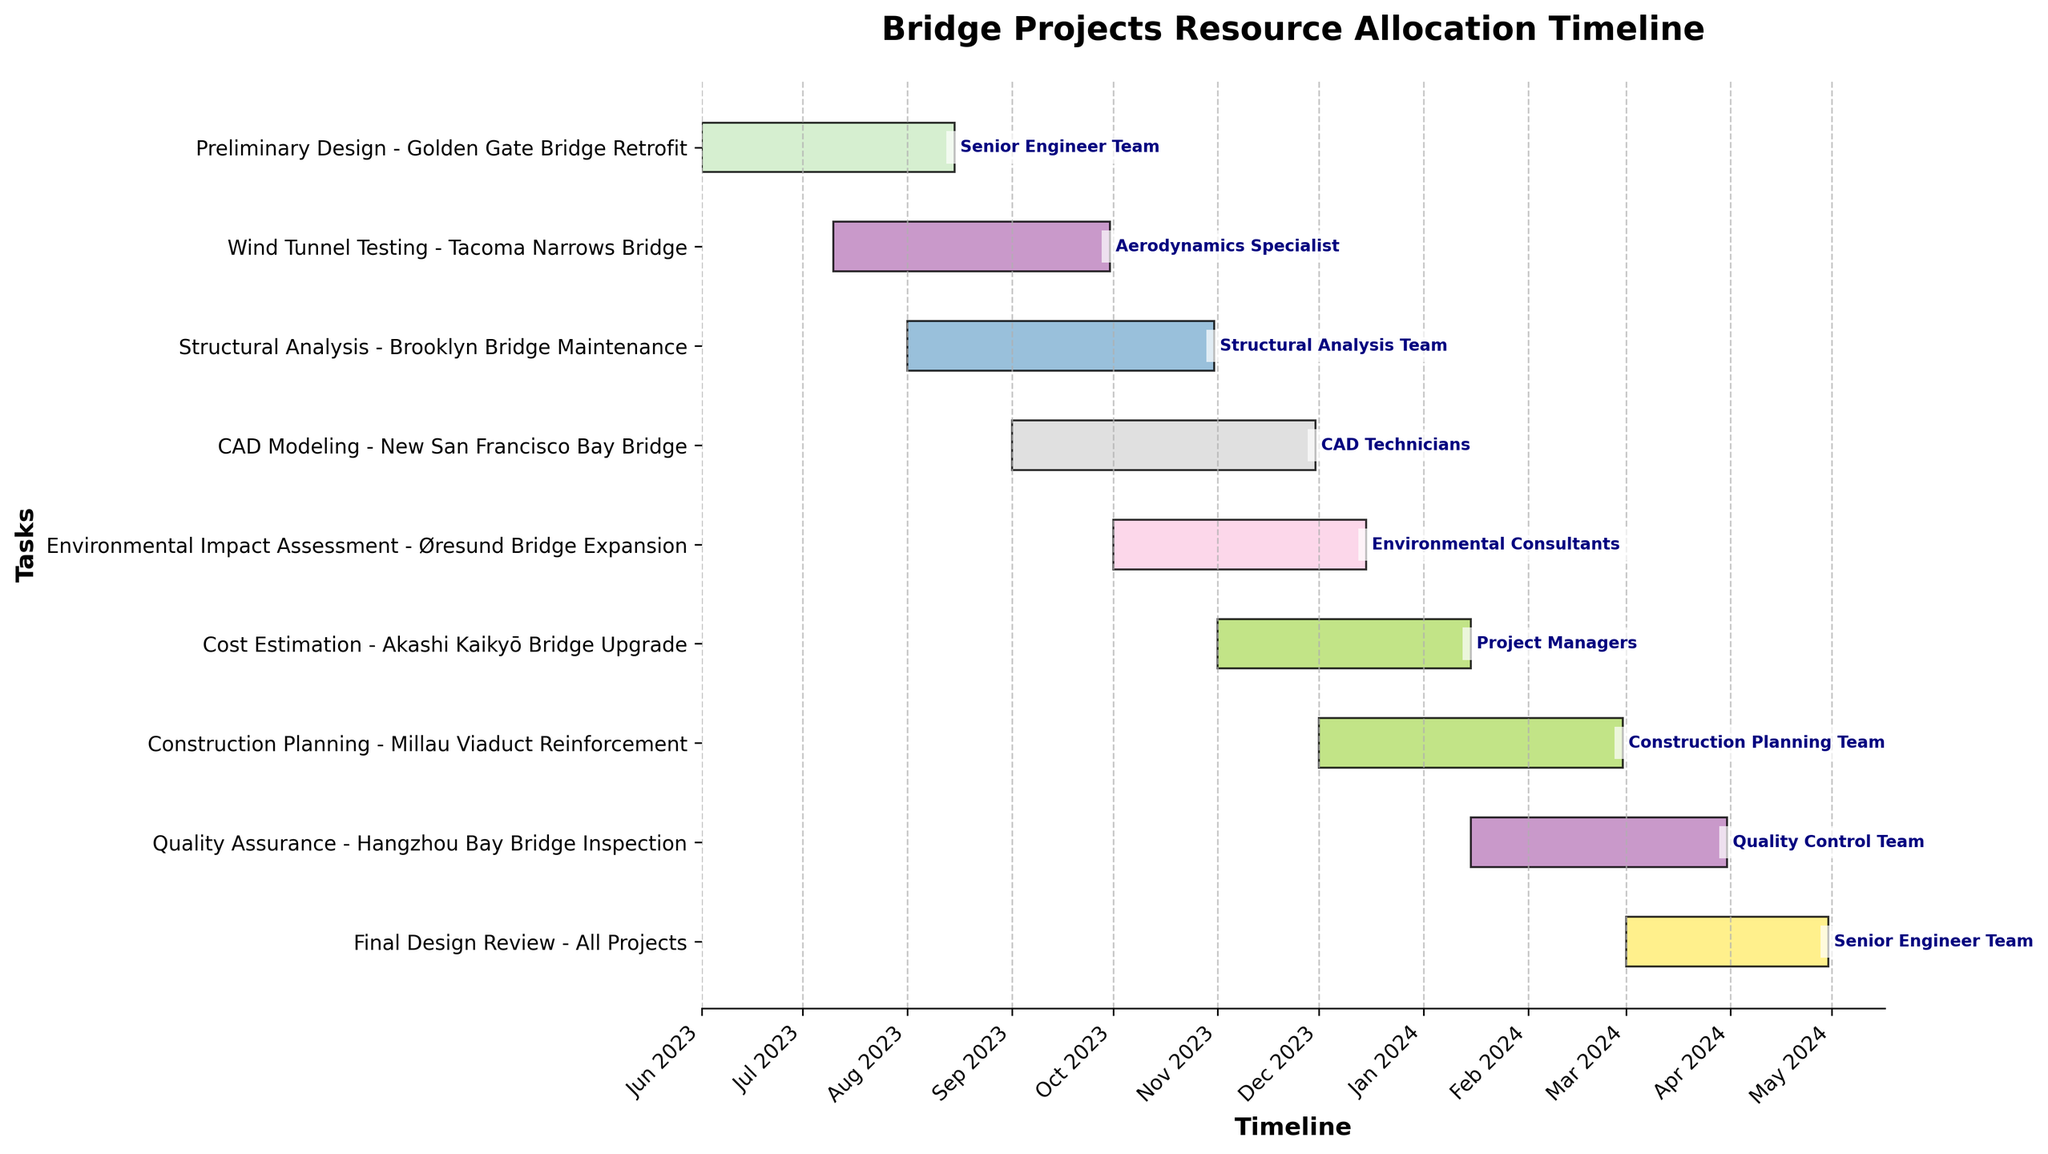What is the title of the plot? Look at the top of the figure, the text there represents the title of the plot.
Answer: Bridge Projects Resource Allocation Timeline Which task is scheduled to start first? Check the starting dates of all tasks and find the one that starts the earliest.
Answer: Preliminary Design - Golden Gate Bridge Retrofit How many tasks are allocated to the Senior Engineer Team? Identify all tasks assigned to the Senior Engineer Team by looking at the resource labels.
Answer: Two Which task has the longest duration? Calculate the duration of each task by finding the difference between its start and end dates and identify the longest one.
Answer: Structural Analysis - Brooklyn Bridge Maintenance Are there any tasks that overlap in time? Compare the date ranges of different tasks to see if any of them overlap with each other.
Answer: Yes Which month has the most tasks starting? Count the number of tasks starting in each month and identify the month with the highest count.
Answer: September 2023 How many resources are allocated to projects starting in October 2023? Identify tasks that start in October 2023 and count the unique resources associated with them.
Answer: Two Which task ends last in the entire timeline? Look at the end dates of all tasks and find the latest date.
Answer: Quality Assurance - Hangzhou Bay Bridge Inspection What resources are involved in tasks starting in November 2023? Identify tasks with start dates in November 2023 and note their associated resources.
Answer: Project Managers Which task follows directly after the "Wind Tunnel Testing - Tacoma Narrows Bridge" in terms of timeline? Identify the tasks starting closest after the end of "Wind Tunnel Testing - Tacoma Narrows Bridge."
Answer: Structural Analysis - Brooklyn Bridge Maintenance 